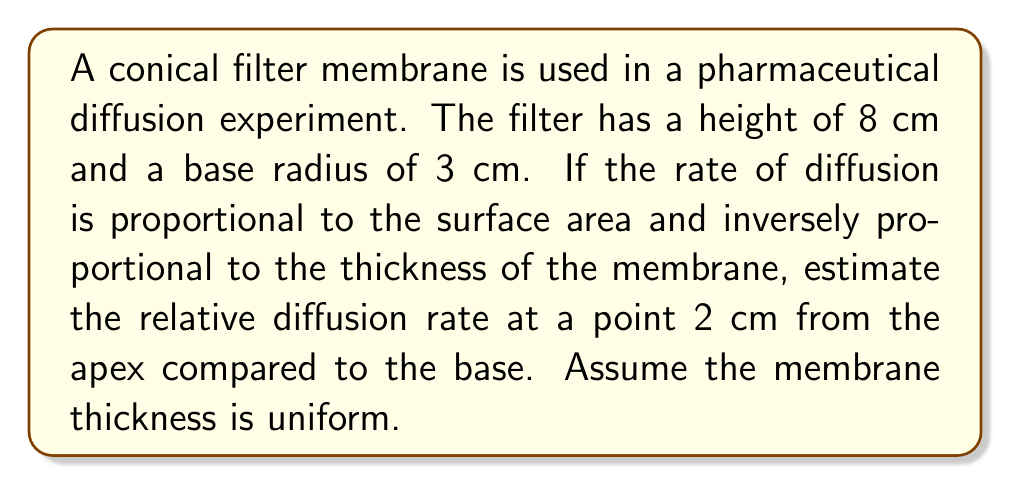Solve this math problem. To solve this problem, we need to follow these steps:

1. Calculate the slant height of the cone:
   Let $r$ be the radius at any point and $h$ be the height from the apex to that point.
   $$r = \frac{3}{8}h$$
   Using the Pythagorean theorem:
   $$l^2 = r^2 + h^2 = (\frac{3}{8}h)^2 + h^2 = \frac{73}{64}h^2$$
   $$l = \frac{\sqrt{73}}{8}h$$

2. Calculate the radius at 2 cm from the apex:
   $$r_2 = \frac{3}{8} \cdot 2 = 0.75 \text{ cm}$$

3. Calculate the surface area of a circular cross-section at 2 cm:
   $$A_2 = \pi r_2^2 = \pi (0.75)^2 \approx 1.77 \text{ cm}^2$$

4. Calculate the surface area of the base:
   $$A_b = \pi r_b^2 = \pi (3)^2 = 28.27 \text{ cm}^2$$

5. Calculate the relative diffusion rate:
   The diffusion rate is proportional to the surface area and inversely proportional to the distance from the apex.
   Relative rate at 2 cm: $R_2 = \frac{A_2}{2} = \frac{1.77}{2} = 0.885$
   Relative rate at base: $R_b = \frac{A_b}{8} = \frac{28.27}{8} = 3.53$

6. Compare the rates:
   $$\text{Ratio} = \frac{R_2}{R_b} = \frac{0.885}{3.53} \approx 0.251$$

[asy]
import geometry;

size(200);
pair A=(0,0), B=(3,0), C=(0,8);
draw(A--B--C--A);
draw((0,2)--(0.75,2),dashed);
label("8 cm",C--A,W);
label("3 cm",A--B,S);
label("2 cm",(0,0)--(0,2),W);
label("0.75 cm",(0,2)--(0.75,2),N);
[/asy]
Answer: 0.251 